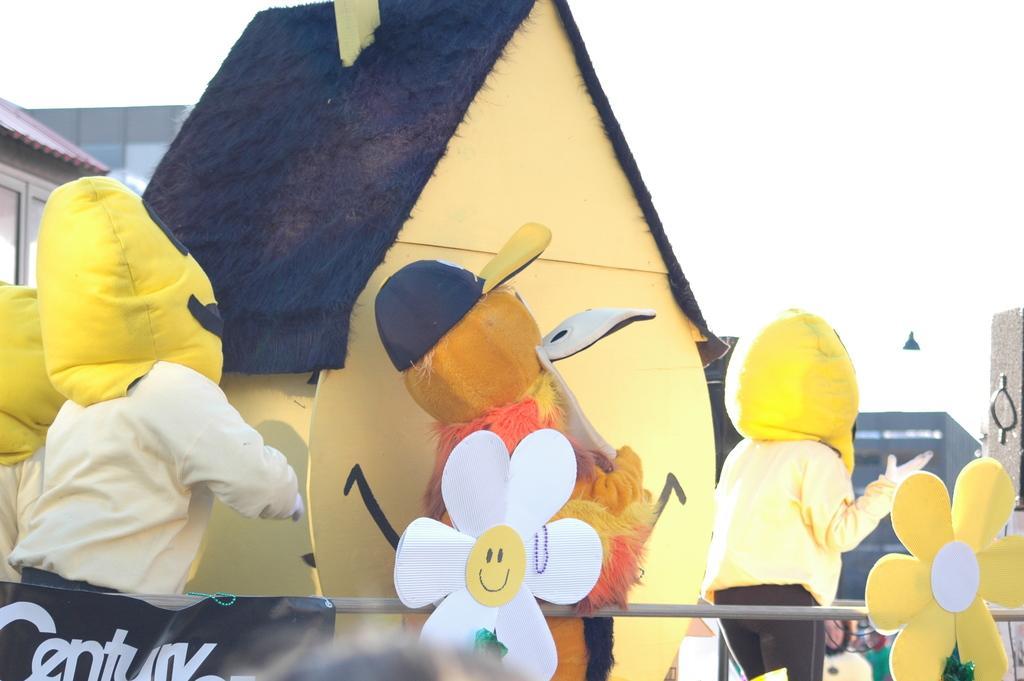Could you give a brief overview of what you see in this image? At the bottom of this image, there are four children, wearing masks and on a platform. Beside them, there is a fence having two flowers and a black color banner and there is a statue. In the background, there is a pole, there are buildings and there is sky. 